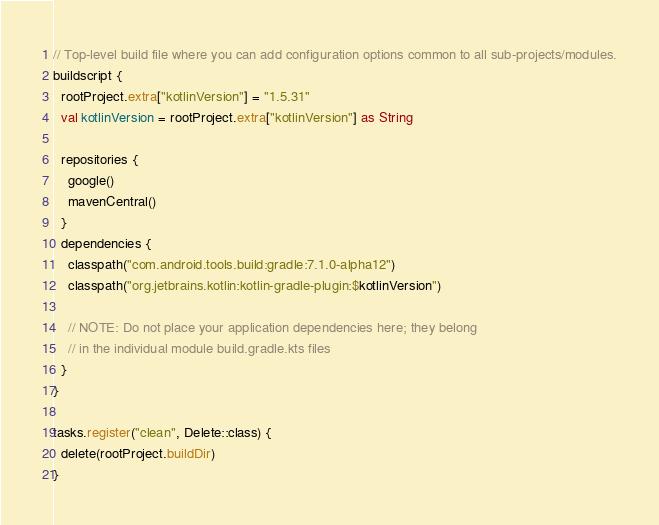Convert code to text. <code><loc_0><loc_0><loc_500><loc_500><_Kotlin_>// Top-level build file where you can add configuration options common to all sub-projects/modules.
buildscript {
  rootProject.extra["kotlinVersion"] = "1.5.31"
  val kotlinVersion = rootProject.extra["kotlinVersion"] as String

  repositories {
    google()
    mavenCentral()
  }
  dependencies {
    classpath("com.android.tools.build:gradle:7.1.0-alpha12")
    classpath("org.jetbrains.kotlin:kotlin-gradle-plugin:$kotlinVersion")

    // NOTE: Do not place your application dependencies here; they belong
    // in the individual module build.gradle.kts files
  }
}

tasks.register("clean", Delete::class) {
  delete(rootProject.buildDir)
}</code> 